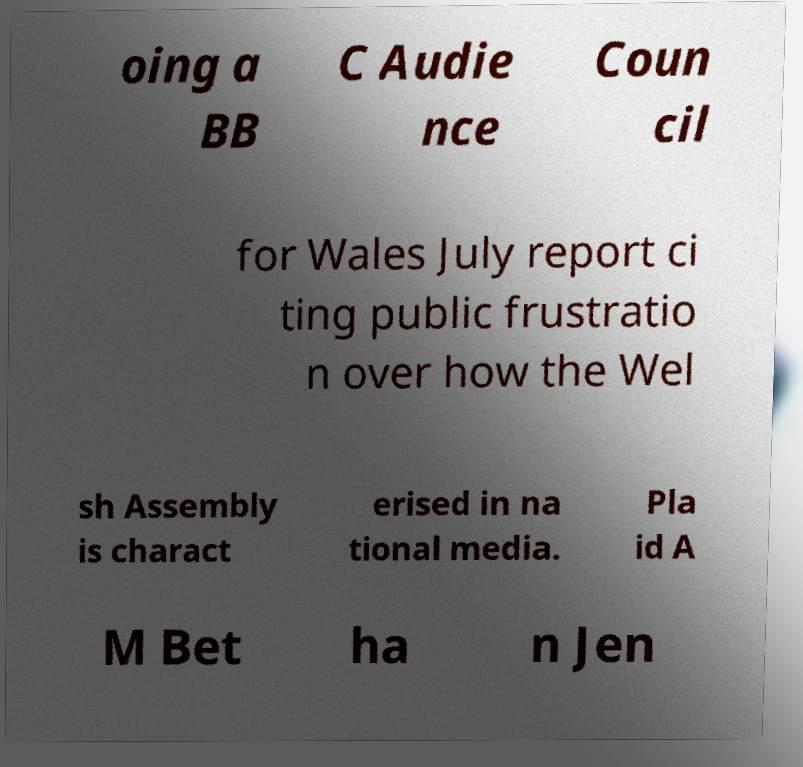I need the written content from this picture converted into text. Can you do that? oing a BB C Audie nce Coun cil for Wales July report ci ting public frustratio n over how the Wel sh Assembly is charact erised in na tional media. Pla id A M Bet ha n Jen 